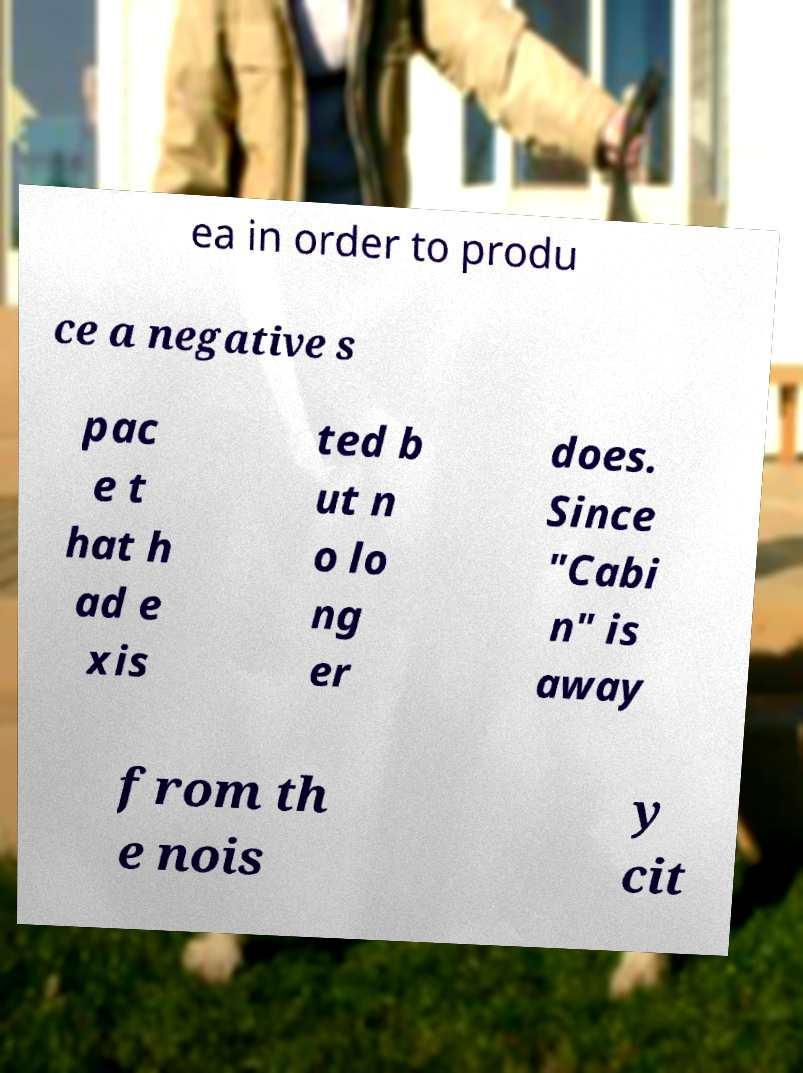I need the written content from this picture converted into text. Can you do that? ea in order to produ ce a negative s pac e t hat h ad e xis ted b ut n o lo ng er does. Since "Cabi n" is away from th e nois y cit 